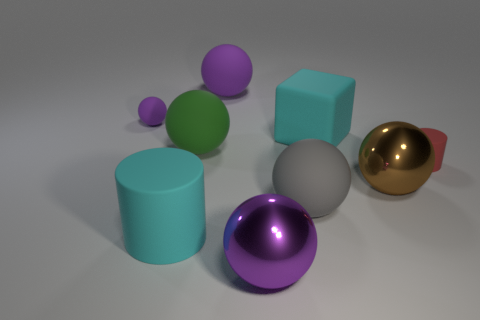Is the shape of the purple thing in front of the large cyan matte cube the same as  the brown metallic thing?
Make the answer very short. Yes. There is a big metallic sphere that is left of the big rubber thing that is to the right of the gray ball; what color is it?
Offer a terse response. Purple. Are there fewer big cubes than tiny green shiny cubes?
Keep it short and to the point. No. Is there a tiny red object that has the same material as the green thing?
Provide a short and direct response. Yes. There is a gray object; does it have the same shape as the small object that is to the right of the gray ball?
Give a very brief answer. No. There is a cyan rubber cube; are there any large gray matte spheres behind it?
Keep it short and to the point. No. What number of large gray metallic objects are the same shape as the large brown shiny thing?
Keep it short and to the point. 0. Does the brown sphere have the same material as the small thing on the left side of the purple shiny object?
Offer a terse response. No. What number of blue rubber cylinders are there?
Your answer should be very brief. 0. There is a metallic thing that is right of the gray object; what is its size?
Offer a terse response. Large. 